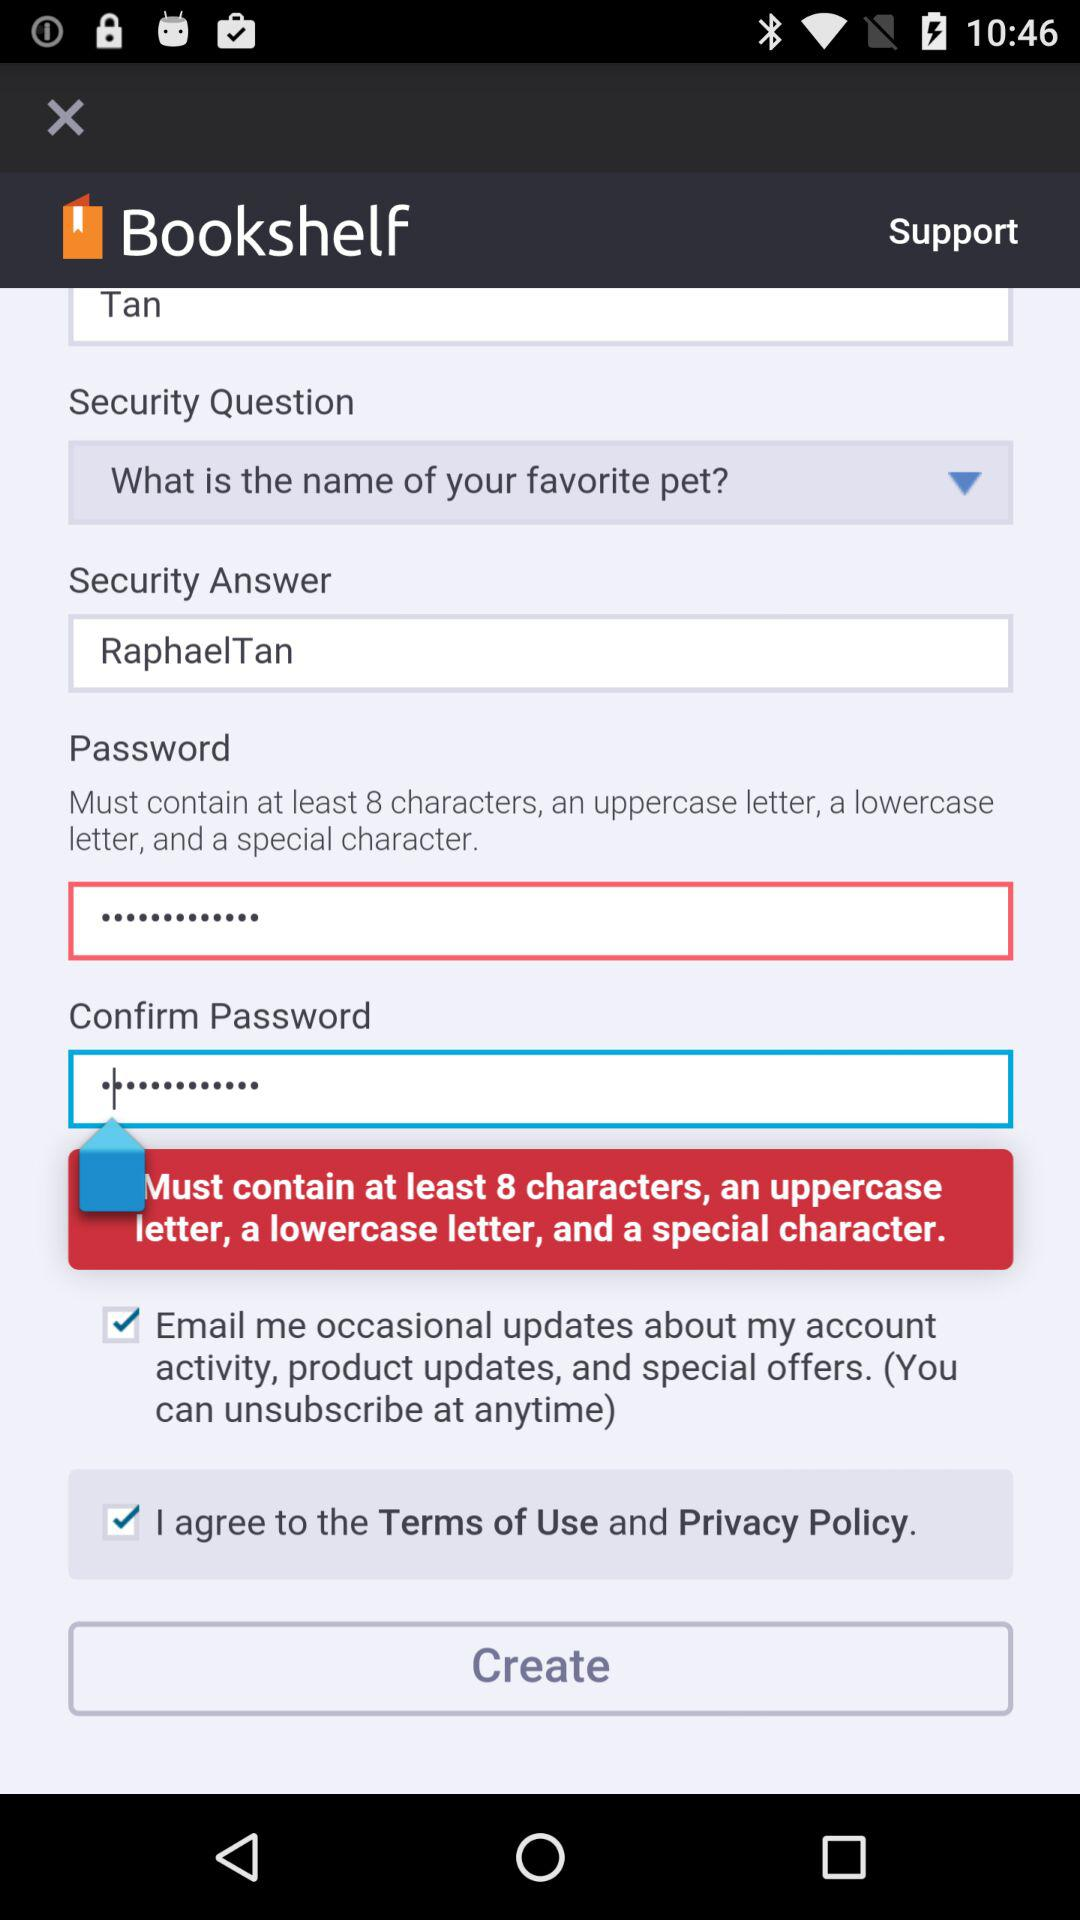What is the minimum character length for the password? The minimum length for the password is at least 8 characters. 